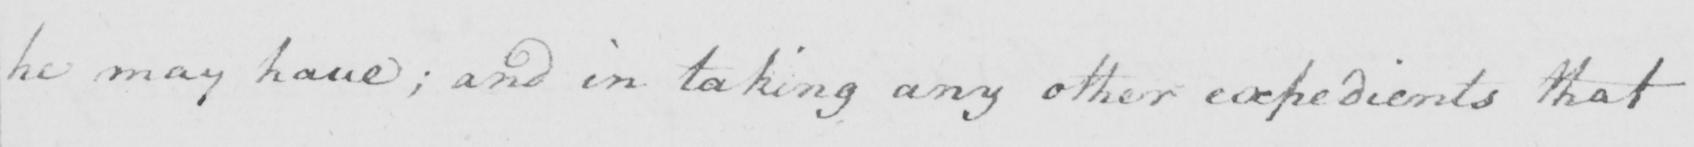Can you tell me what this handwritten text says? he may have ; and in taking any other expedients that 